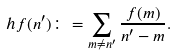<formula> <loc_0><loc_0><loc_500><loc_500>h f ( n ^ { \prime } ) \colon = \sum _ { m \neq n ^ { \prime } } \frac { f ( m ) } { n ^ { \prime } - m } .</formula> 